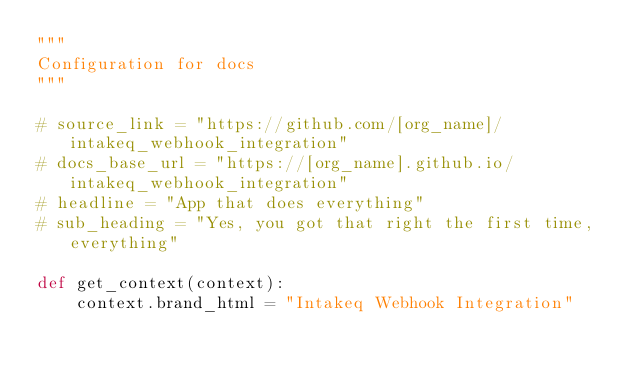Convert code to text. <code><loc_0><loc_0><loc_500><loc_500><_Python_>"""
Configuration for docs
"""

# source_link = "https://github.com/[org_name]/intakeq_webhook_integration"
# docs_base_url = "https://[org_name].github.io/intakeq_webhook_integration"
# headline = "App that does everything"
# sub_heading = "Yes, you got that right the first time, everything"

def get_context(context):
	context.brand_html = "Intakeq Webhook Integration"
</code> 